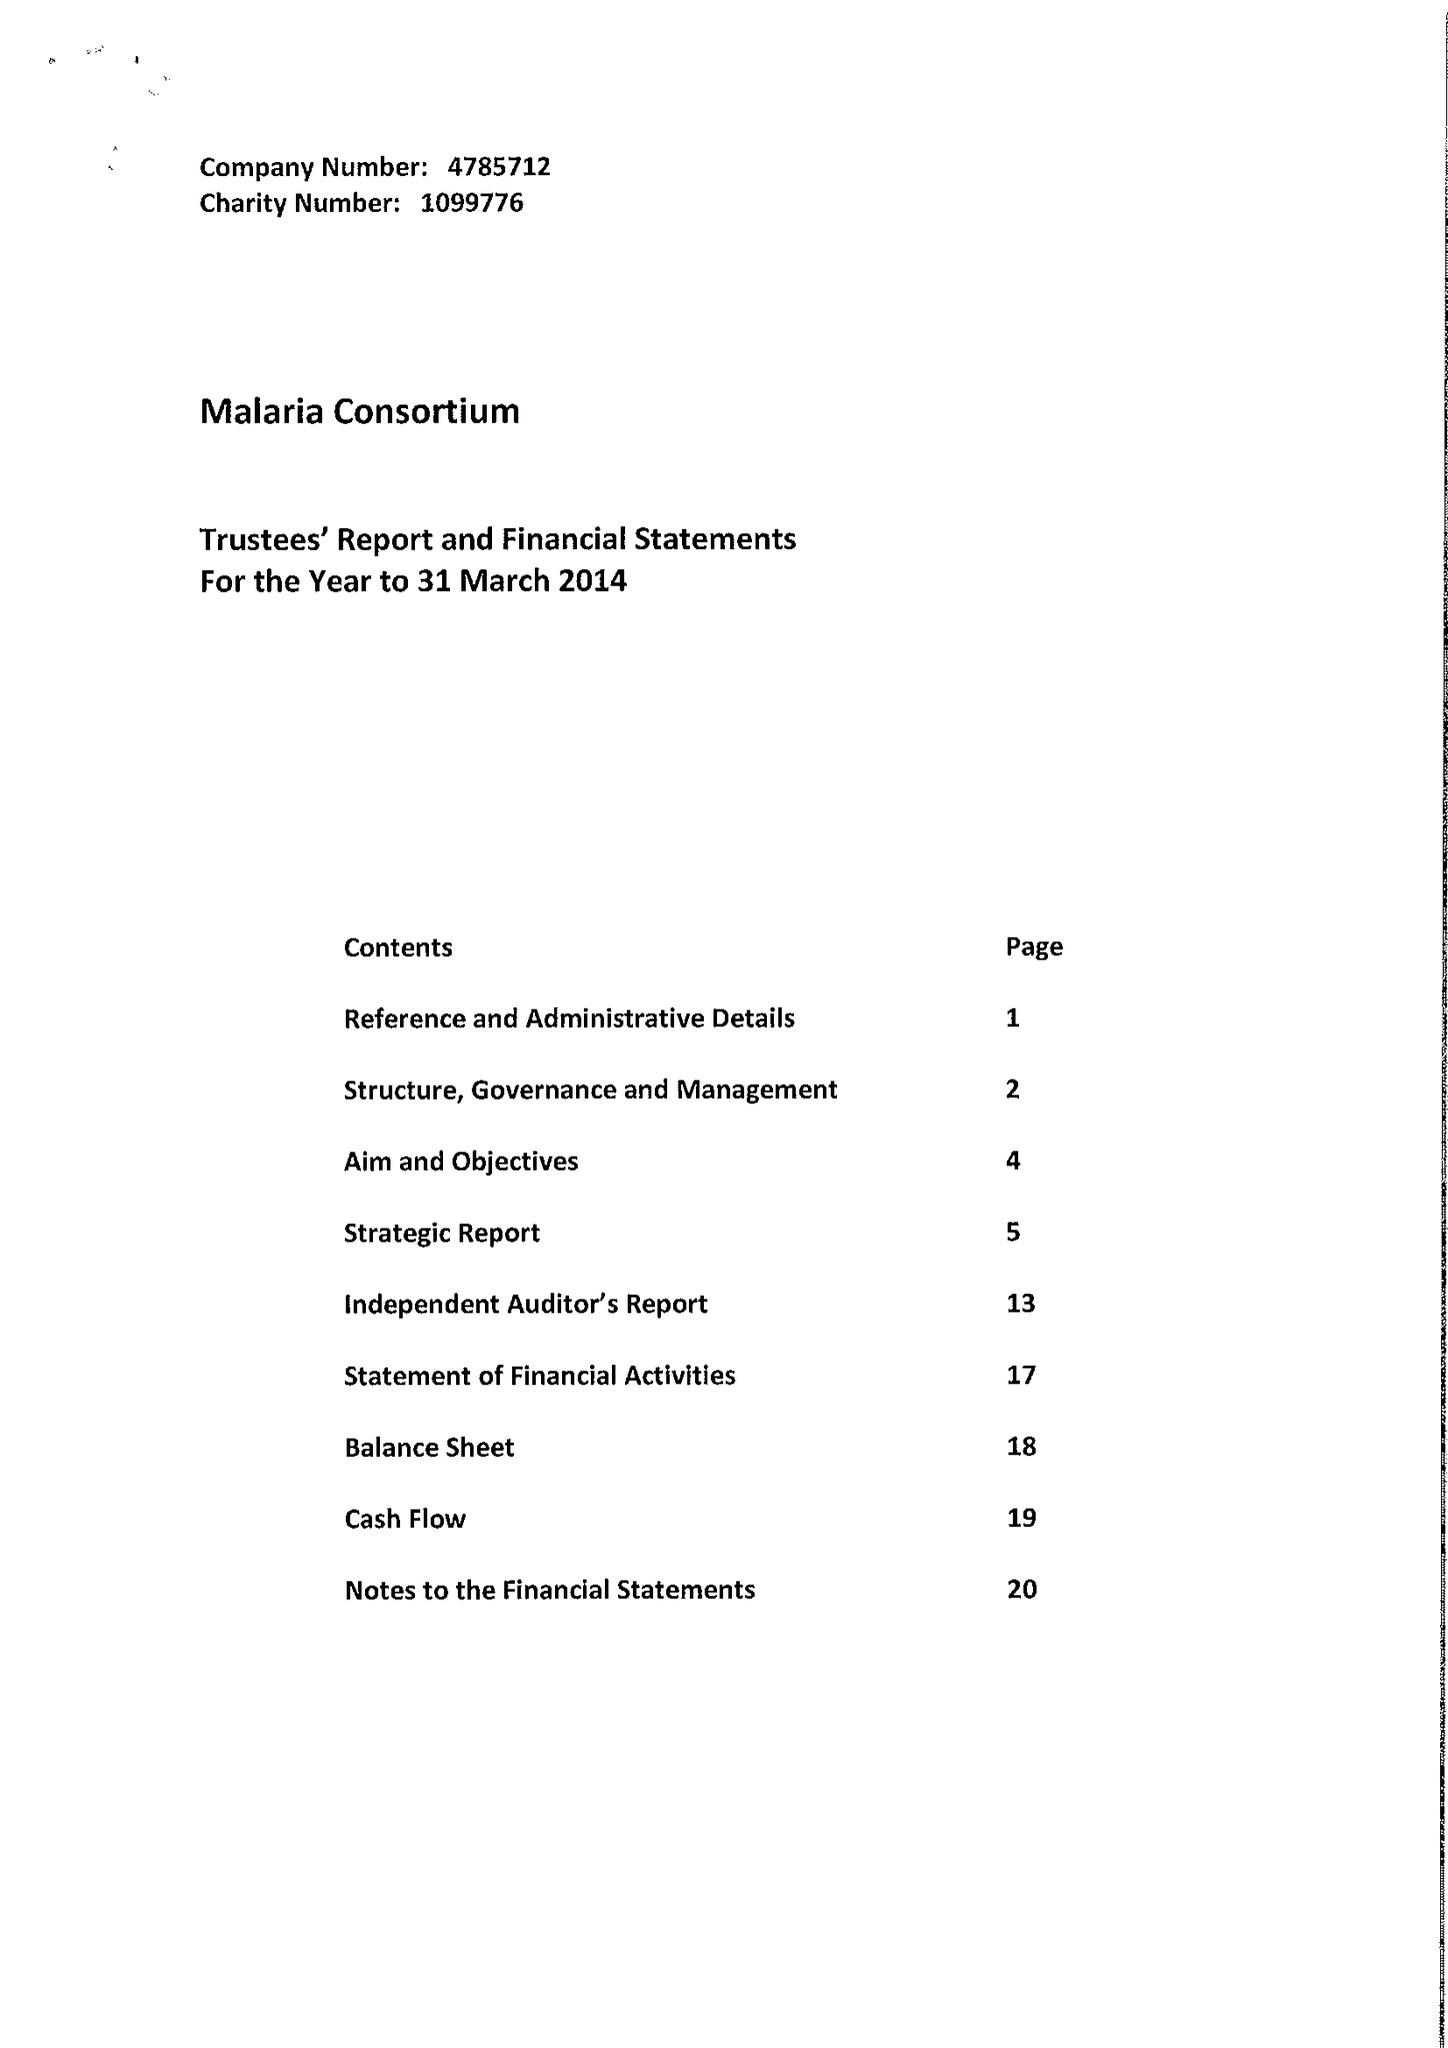What is the value for the charity_name?
Answer the question using a single word or phrase. Malaria Consortium 